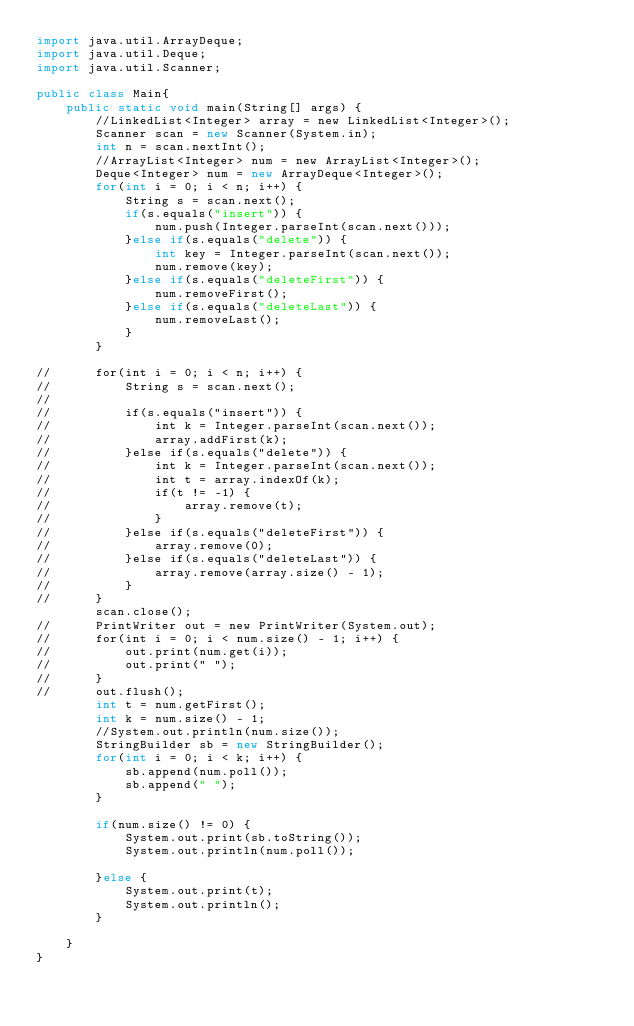<code> <loc_0><loc_0><loc_500><loc_500><_Java_>import java.util.ArrayDeque;
import java.util.Deque;
import java.util.Scanner;

public class Main{
	public static void main(String[] args) {
		//LinkedList<Integer> array = new LinkedList<Integer>();
		Scanner scan = new Scanner(System.in);
		int n = scan.nextInt();
		//ArrayList<Integer> num = new ArrayList<Integer>();
		Deque<Integer> num = new ArrayDeque<Integer>();
		for(int i = 0; i < n; i++) {
			String s = scan.next();
			if(s.equals("insert")) {
				num.push(Integer.parseInt(scan.next()));
			}else if(s.equals("delete")) {
				int key = Integer.parseInt(scan.next());
				num.remove(key);
			}else if(s.equals("deleteFirst")) {
				num.removeFirst();
			}else if(s.equals("deleteLast")) {
				num.removeLast();
			}
		}

//		for(int i = 0; i < n; i++) {
//			String s = scan.next();
//
//			if(s.equals("insert")) {
//				int k = Integer.parseInt(scan.next());
//				array.addFirst(k);
//			}else if(s.equals("delete")) {
//				int k = Integer.parseInt(scan.next());
//				int t = array.indexOf(k);
//				if(t != -1) {
//					array.remove(t);
//				}
//			}else if(s.equals("deleteFirst")) {
//				array.remove(0);
//			}else if(s.equals("deleteLast")) {
//				array.remove(array.size() - 1);
//			}
//		}
		scan.close();
//		PrintWriter out = new PrintWriter(System.out);
//		for(int i = 0; i < num.size() - 1; i++) {
//			out.print(num.get(i));
//			out.print(" ");
//		}
//		out.flush();
		int t = num.getFirst();
		int k = num.size() - 1;
		//System.out.println(num.size());
		StringBuilder sb = new StringBuilder();
		for(int i = 0; i < k; i++) {
			sb.append(num.poll());
			sb.append(" ");
		}

		if(num.size() != 0) {
			System.out.print(sb.toString());
			System.out.println(num.poll());

		}else {
			System.out.print(t);
			System.out.println();
		}

	}
}
</code> 